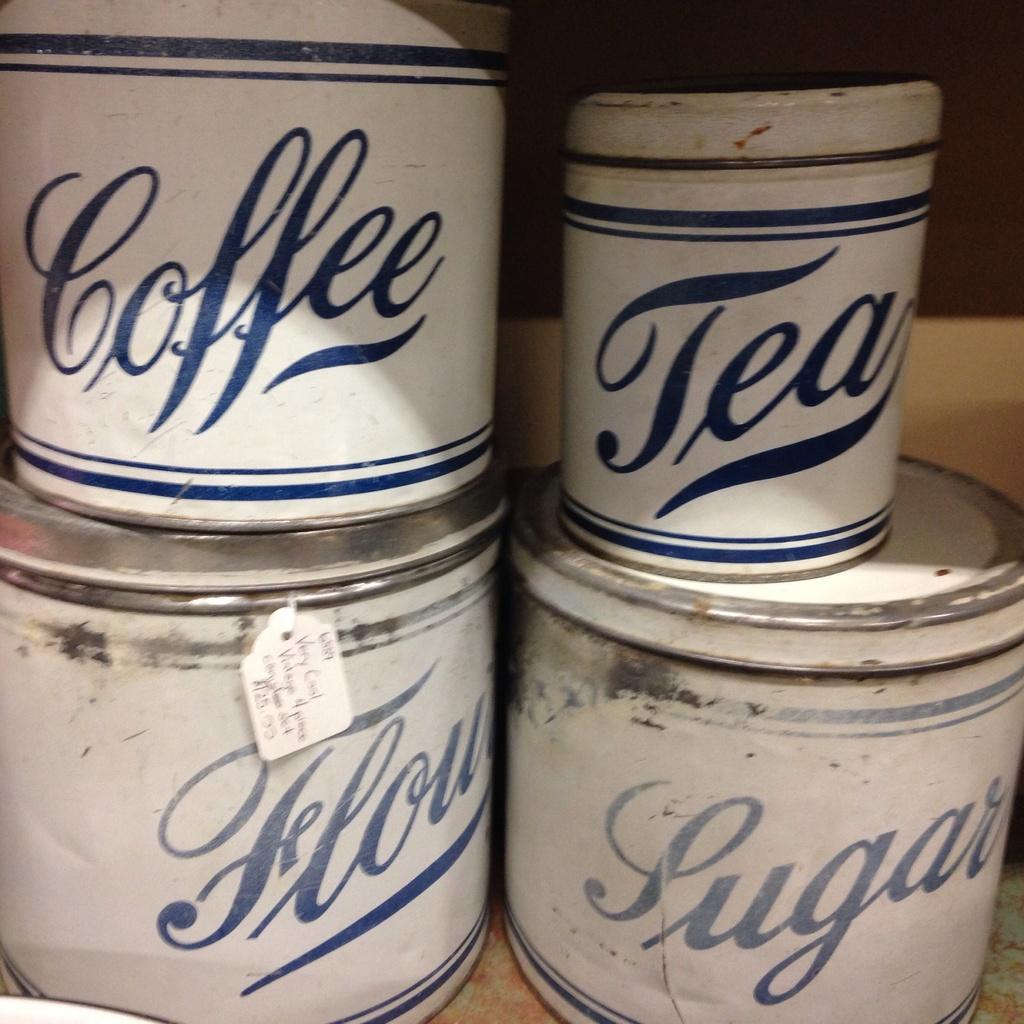<image>
Present a compact description of the photo's key features. Old rusted white canisters are labeled coffee, tea, four and sugar. 